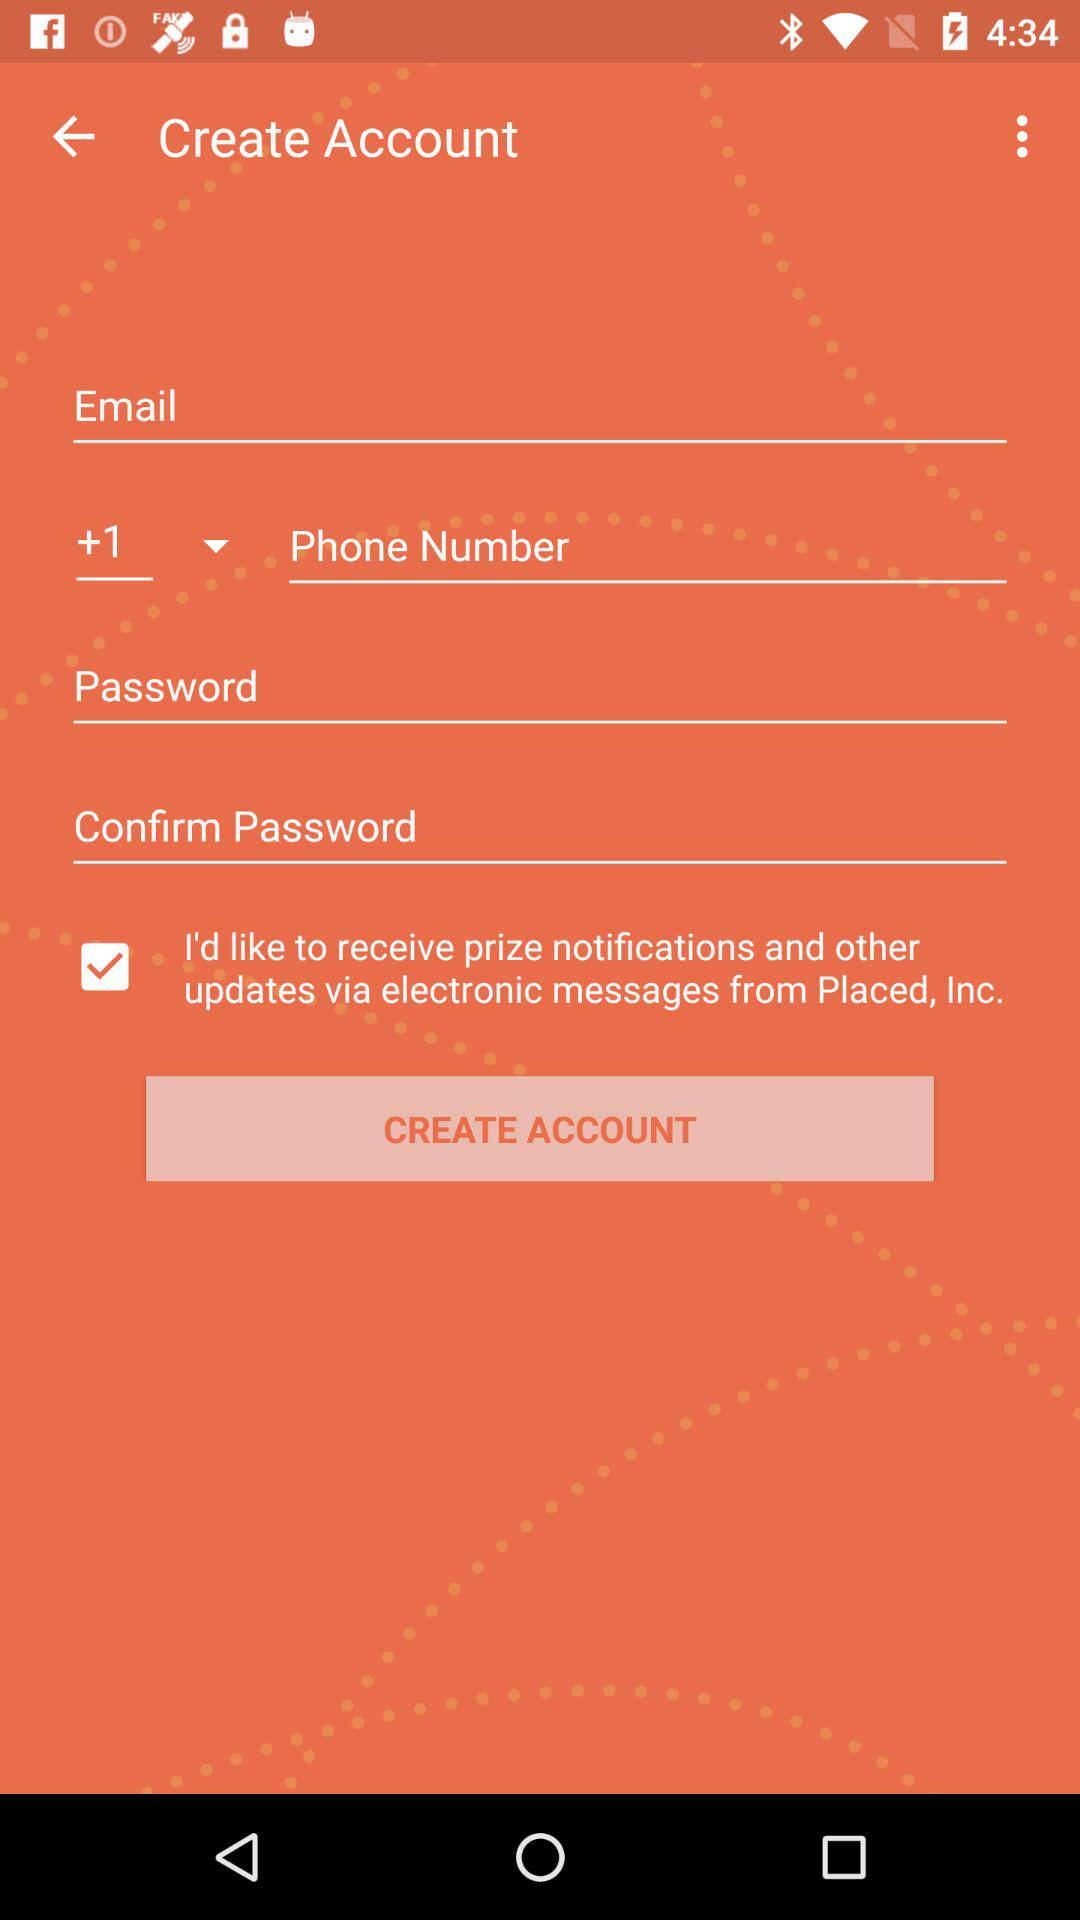How many characters are required to create a password?
When the provided information is insufficient, respond with <no answer>. <no answer> 